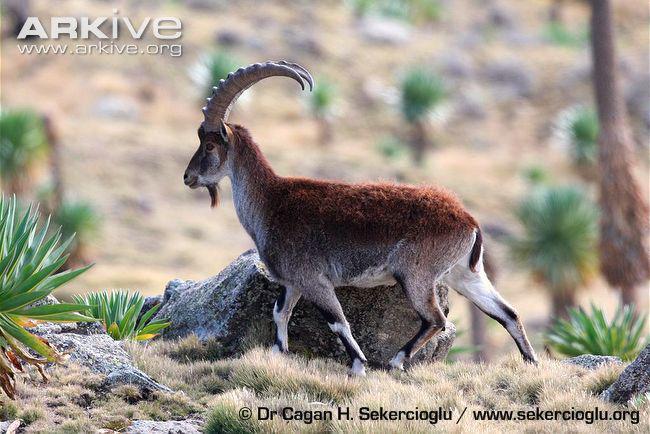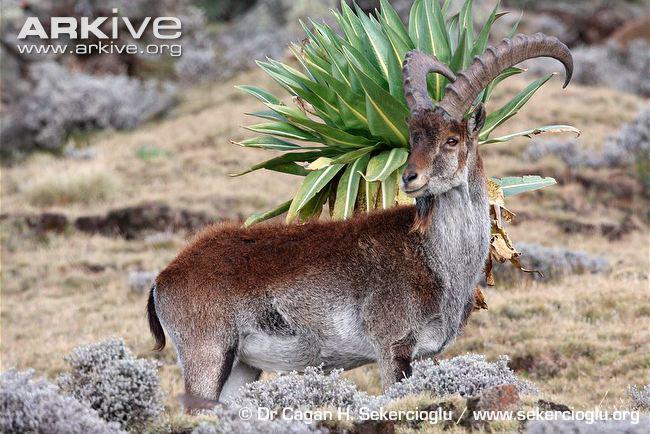The first image is the image on the left, the second image is the image on the right. For the images displayed, is the sentence "The left and right image contains the same number of goats standing in opposite directions." factually correct? Answer yes or no. Yes. The first image is the image on the left, the second image is the image on the right. Analyze the images presented: Is the assertion "Each image depicts one horned animal, and the horned animals in the left and right images face the same direction." valid? Answer yes or no. No. 